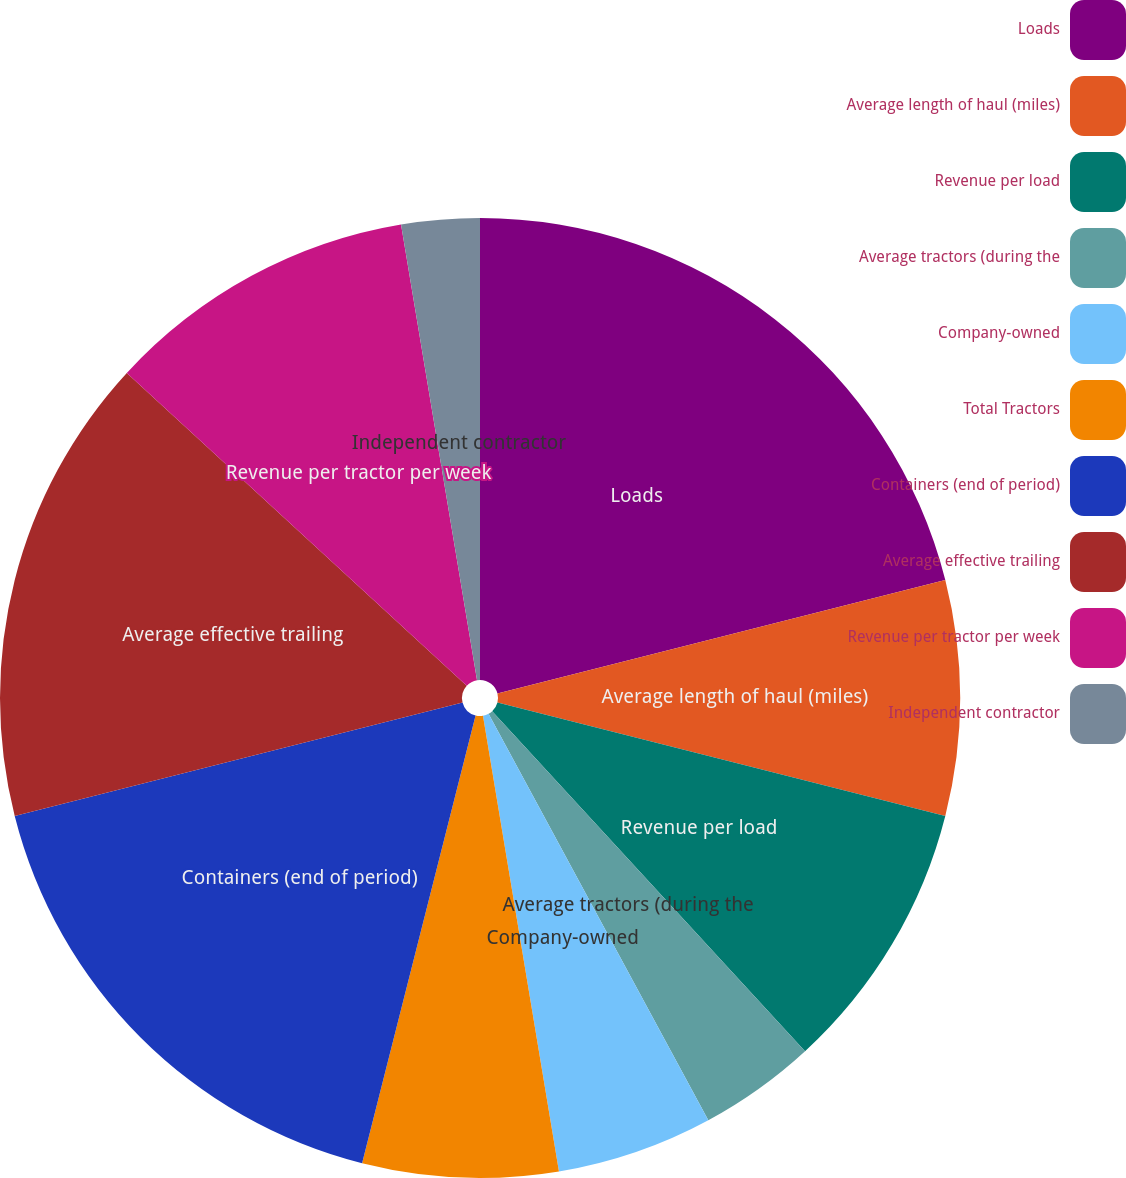Convert chart to OTSL. <chart><loc_0><loc_0><loc_500><loc_500><pie_chart><fcel>Loads<fcel>Average length of haul (miles)<fcel>Revenue per load<fcel>Average tractors (during the<fcel>Company-owned<fcel>Total Tractors<fcel>Containers (end of period)<fcel>Average effective trailing<fcel>Revenue per tractor per week<fcel>Independent contractor<nl><fcel>21.05%<fcel>7.9%<fcel>9.21%<fcel>3.95%<fcel>5.26%<fcel>6.58%<fcel>17.1%<fcel>15.79%<fcel>10.53%<fcel>2.63%<nl></chart> 